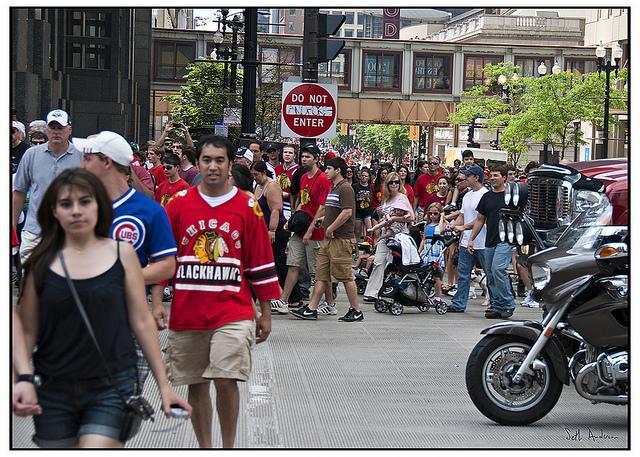How many baby strollers are there?
Give a very brief answer. 1. How many people are there?
Give a very brief answer. 9. How many dogs are on a leash?
Give a very brief answer. 0. 